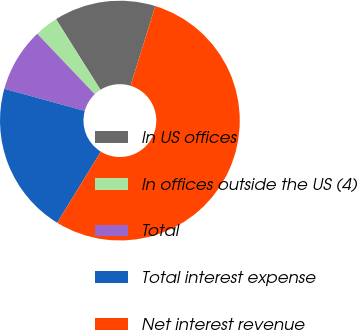<chart> <loc_0><loc_0><loc_500><loc_500><pie_chart><fcel>In US offices<fcel>In offices outside the US (4)<fcel>Total<fcel>Total interest expense<fcel>Net interest revenue<nl><fcel>13.71%<fcel>3.16%<fcel>8.62%<fcel>20.51%<fcel>53.99%<nl></chart> 